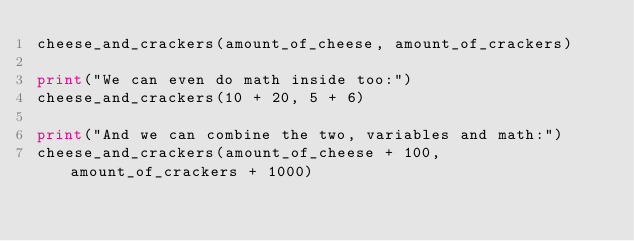<code> <loc_0><loc_0><loc_500><loc_500><_Python_>cheese_and_crackers(amount_of_cheese, amount_of_crackers)

print("We can even do math inside too:")
cheese_and_crackers(10 + 20, 5 + 6)

print("And we can combine the two, variables and math:")
cheese_and_crackers(amount_of_cheese + 100, amount_of_crackers + 1000)

</code> 